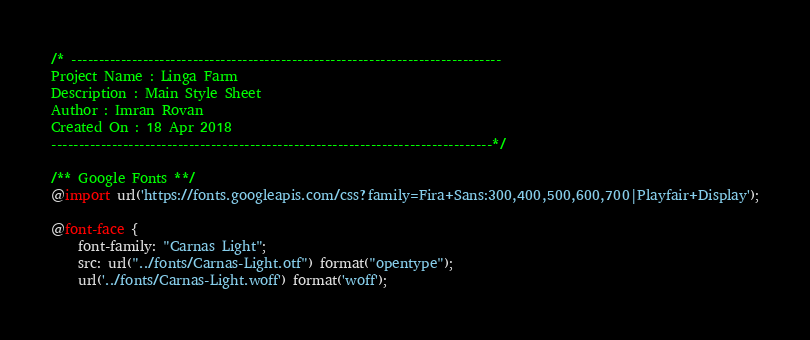Convert code to text. <code><loc_0><loc_0><loc_500><loc_500><_CSS_>/* ------------------------------------------------------------------------------ 
Project Name : Linga Farm 
Description : Main Style Sheet 
Author : Imran Rovan 
Created On : 18 Apr 2018 
--------------------------------------------------------------------------------*/

/** Google Fonts **/
@import url('https://fonts.googleapis.com/css?family=Fira+Sans:300,400,500,600,700|Playfair+Display');

@font-face {
	font-family: "Carnas Light";
	src: url("../fonts/Carnas-Light.otf") format("opentype");
	url('../fonts/Carnas-Light.woff') format('woff');</code> 